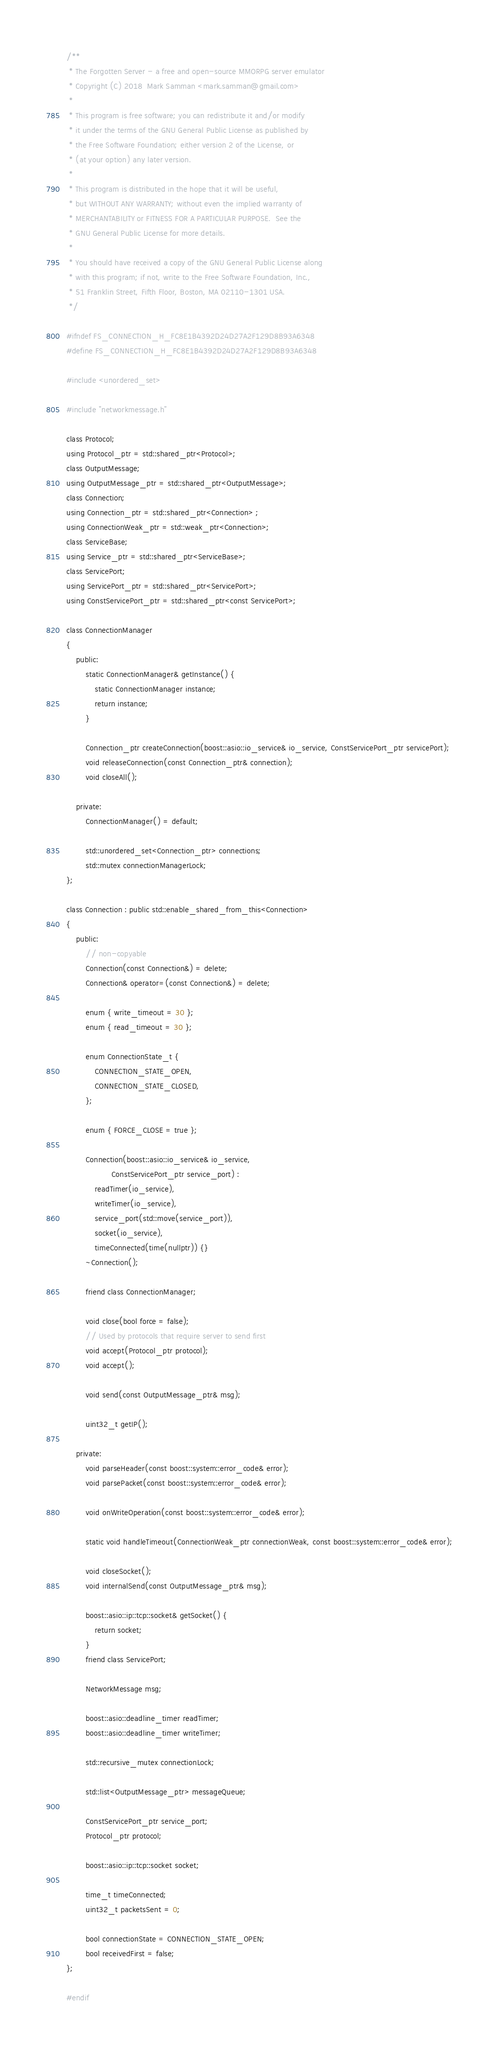<code> <loc_0><loc_0><loc_500><loc_500><_C_>/**
 * The Forgotten Server - a free and open-source MMORPG server emulator
 * Copyright (C) 2018  Mark Samman <mark.samman@gmail.com>
 *
 * This program is free software; you can redistribute it and/or modify
 * it under the terms of the GNU General Public License as published by
 * the Free Software Foundation; either version 2 of the License, or
 * (at your option) any later version.
 *
 * This program is distributed in the hope that it will be useful,
 * but WITHOUT ANY WARRANTY; without even the implied warranty of
 * MERCHANTABILITY or FITNESS FOR A PARTICULAR PURPOSE.  See the
 * GNU General Public License for more details.
 *
 * You should have received a copy of the GNU General Public License along
 * with this program; if not, write to the Free Software Foundation, Inc.,
 * 51 Franklin Street, Fifth Floor, Boston, MA 02110-1301 USA.
 */

#ifndef FS_CONNECTION_H_FC8E1B4392D24D27A2F129D8B93A6348
#define FS_CONNECTION_H_FC8E1B4392D24D27A2F129D8B93A6348

#include <unordered_set>

#include "networkmessage.h"

class Protocol;
using Protocol_ptr = std::shared_ptr<Protocol>;
class OutputMessage;
using OutputMessage_ptr = std::shared_ptr<OutputMessage>;
class Connection;
using Connection_ptr = std::shared_ptr<Connection> ;
using ConnectionWeak_ptr = std::weak_ptr<Connection>;
class ServiceBase;
using Service_ptr = std::shared_ptr<ServiceBase>;
class ServicePort;
using ServicePort_ptr = std::shared_ptr<ServicePort>;
using ConstServicePort_ptr = std::shared_ptr<const ServicePort>;

class ConnectionManager
{
	public:
		static ConnectionManager& getInstance() {
			static ConnectionManager instance;
			return instance;
		}

		Connection_ptr createConnection(boost::asio::io_service& io_service, ConstServicePort_ptr servicePort);
		void releaseConnection(const Connection_ptr& connection);
		void closeAll();

	private:
		ConnectionManager() = default;

		std::unordered_set<Connection_ptr> connections;
		std::mutex connectionManagerLock;
};

class Connection : public std::enable_shared_from_this<Connection>
{
	public:
		// non-copyable
		Connection(const Connection&) = delete;
		Connection& operator=(const Connection&) = delete;

		enum { write_timeout = 30 };
		enum { read_timeout = 30 };

		enum ConnectionState_t {
			CONNECTION_STATE_OPEN,
			CONNECTION_STATE_CLOSED,
		};

		enum { FORCE_CLOSE = true };

		Connection(boost::asio::io_service& io_service,
		           ConstServicePort_ptr service_port) :
			readTimer(io_service),
			writeTimer(io_service),
			service_port(std::move(service_port)),
			socket(io_service),
			timeConnected(time(nullptr)) {}
		~Connection();

		friend class ConnectionManager;

		void close(bool force = false);
		// Used by protocols that require server to send first
		void accept(Protocol_ptr protocol);
		void accept();

		void send(const OutputMessage_ptr& msg);

		uint32_t getIP();

	private:
		void parseHeader(const boost::system::error_code& error);
		void parsePacket(const boost::system::error_code& error);

		void onWriteOperation(const boost::system::error_code& error);

		static void handleTimeout(ConnectionWeak_ptr connectionWeak, const boost::system::error_code& error);

		void closeSocket();
		void internalSend(const OutputMessage_ptr& msg);

		boost::asio::ip::tcp::socket& getSocket() {
			return socket;
		}
		friend class ServicePort;

		NetworkMessage msg;

		boost::asio::deadline_timer readTimer;
		boost::asio::deadline_timer writeTimer;

		std::recursive_mutex connectionLock;

		std::list<OutputMessage_ptr> messageQueue;

		ConstServicePort_ptr service_port;
		Protocol_ptr protocol;

		boost::asio::ip::tcp::socket socket;

		time_t timeConnected;
		uint32_t packetsSent = 0;

		bool connectionState = CONNECTION_STATE_OPEN;
		bool receivedFirst = false;
};

#endif
</code> 